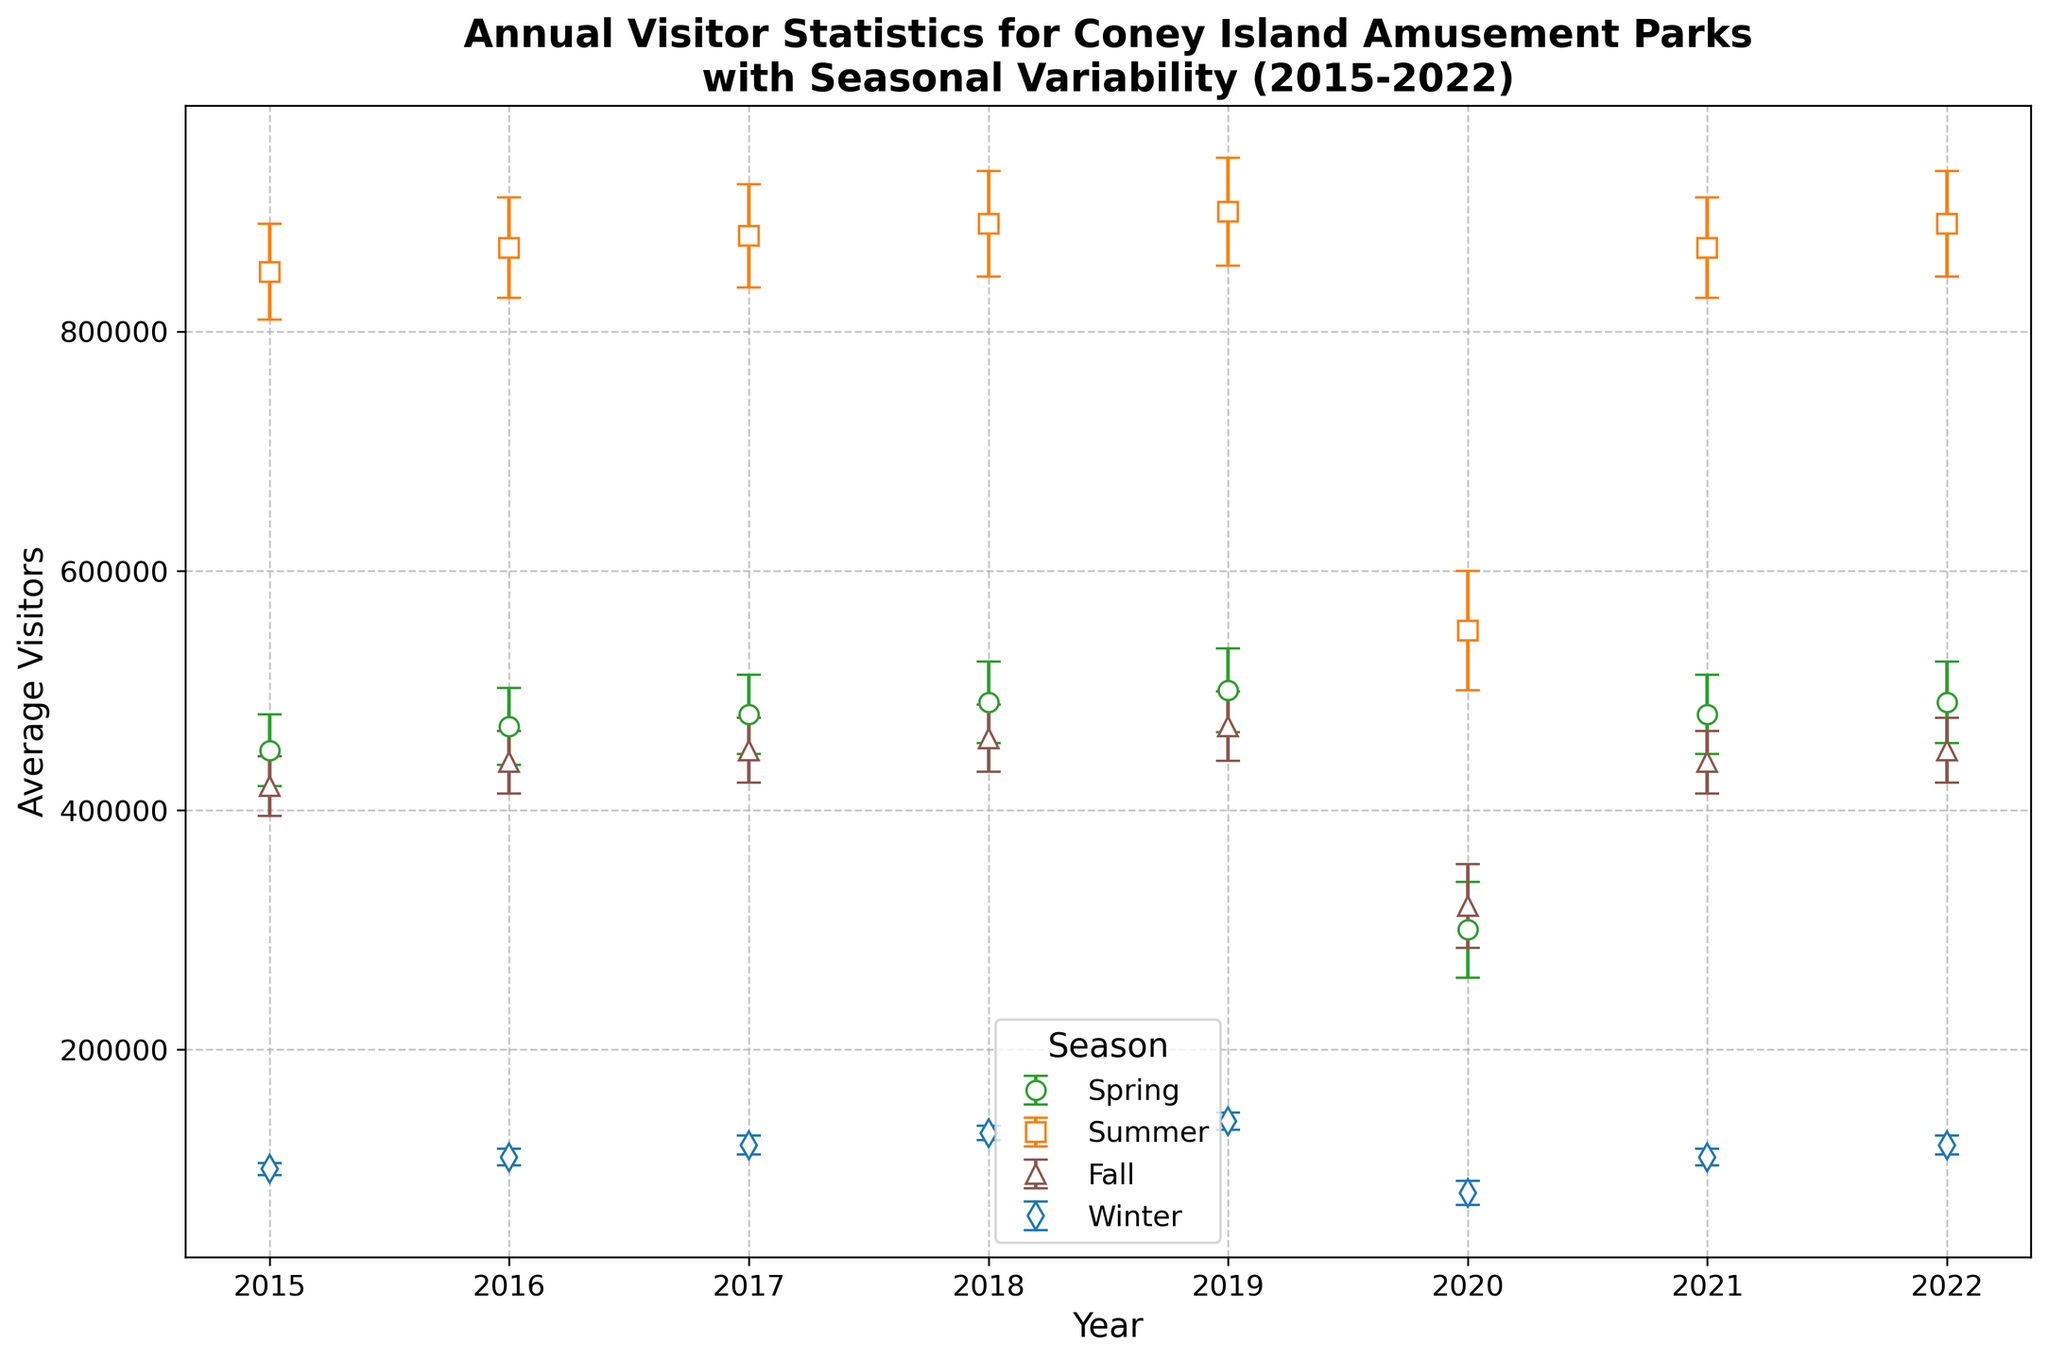what is the average number of visitors to Coney Island amusement parks in summer over the years 2015 to 2022? The figure shows the average visitors each summer from 2015 to 2022. Sum these values (850000 + 870000 + 880000 + 890000 + 900000 + 550000 + 870000 + 890000) and divide by the number of years, which is 8.
Answer: 837500 Which season had the most visitors in 2020? From the figure, in 2020 the visitors were distributed as: Spring (300,000), Summer (550,000), Fall (320,000), Winter (80,000). Summer had the highest with 550,000 visitors.
Answer: Summer How did the average number of visitors in Winter 2022 compare to Winter 2015? The figure indicates Winter average visitors in 2015 were 100,000 and in 2022 were 120,000. 2022 had higher visitors than 2015.
Answer: Higher in 2022 What is the trend of average visitors in Spring from 2015 to 2022? Observing the plot, the Spring visitors start from 450,000 in 2015, slightly increase to 500,000 by 2019, drop significantly in 2020 to 300,000 due to the pandemic, and rise again to 490,000 by 2022. Trend: mostly rising except a dip in 2020.
Answer: Generally increasing with a dip in 2020 Compare the visitor variability in Summer (2020) and Summer (2022). The plot shows the error bars for both years. Summer 2020 error bar signifies a higher standard deviation (~50,000), showing more variability compared to Summer 2022 (~44,000).
Answer: More variable in 2020 What's the difference in average visitors between Summer 2015 and Summer 2022? The figure shows 850,000 visitors in Summer 2015 and 890,000 visitors in Summer 2022. Difference = 890,000 - 850,000 = 40,000.
Answer: 40,000 What seasonal trend can be observed regarding visitor numbers over the years? The figure indicates Summer has the highest visitor numbers consistently, followed by Spring and Fall, with Winter having the lowest visitor numbers each year.
Answer: Highest in Summer, lowest in Winter During which year did Winter see the highest number of visitors, and how many were there? The figure shows Winter 2019 had 140,000 visitors, the highest compared to other winters in the dataset.
Answer: 2019, 140,000 